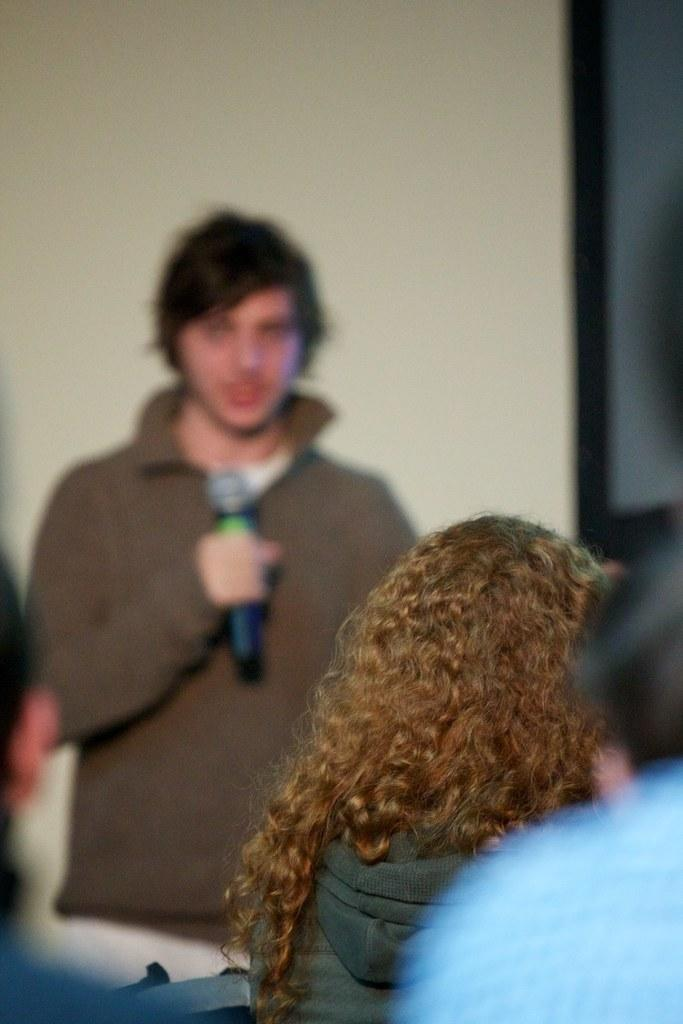What is the person in the image doing? The person is standing and holding a mic. Who else is present in the image? There are people at the bottom of the image. What can be seen in the background of the image? There is a wall in the background of the image. How does the person's breath affect the fire in the image? There is no fire present in the image, so the person's breath does not affect any fire. 